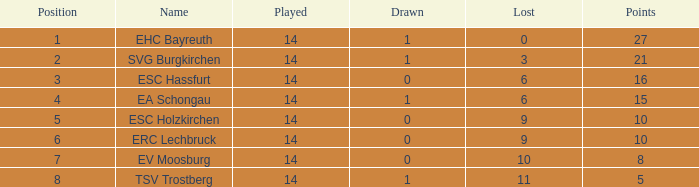What are the point totals for individuals with more than 6 losses, less than 14 games played, and a standing greater than 1? None. 